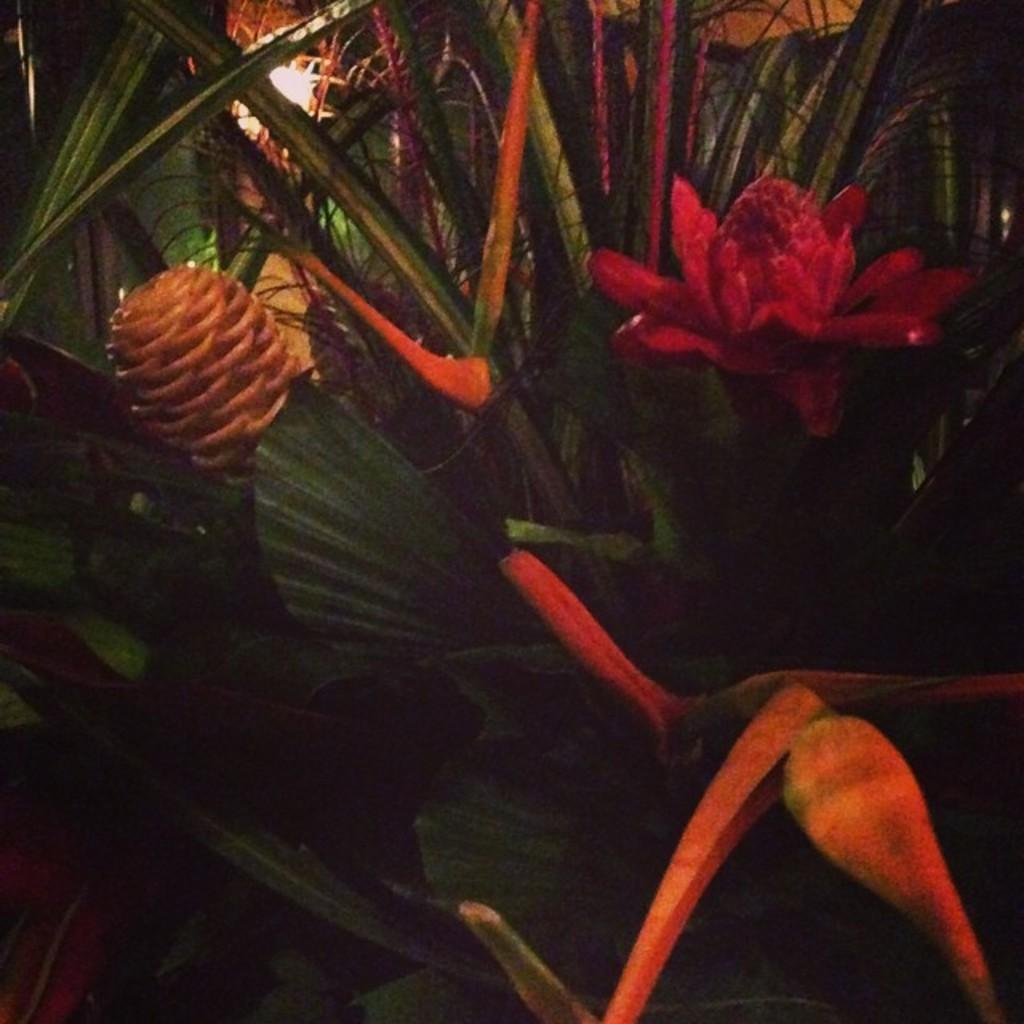What is the main subject of the image? The main subject of the image is a zoomed-in view of plants. Can you describe the flowers in the image? Yes, there is a flower on the right side of the image and another flower on the left side of the image. How much was the payment for the knee surgery of the grandfather in the image? There is no mention of payment, knee surgery, or a grandfather in the image. The image only features plants and flowers. 